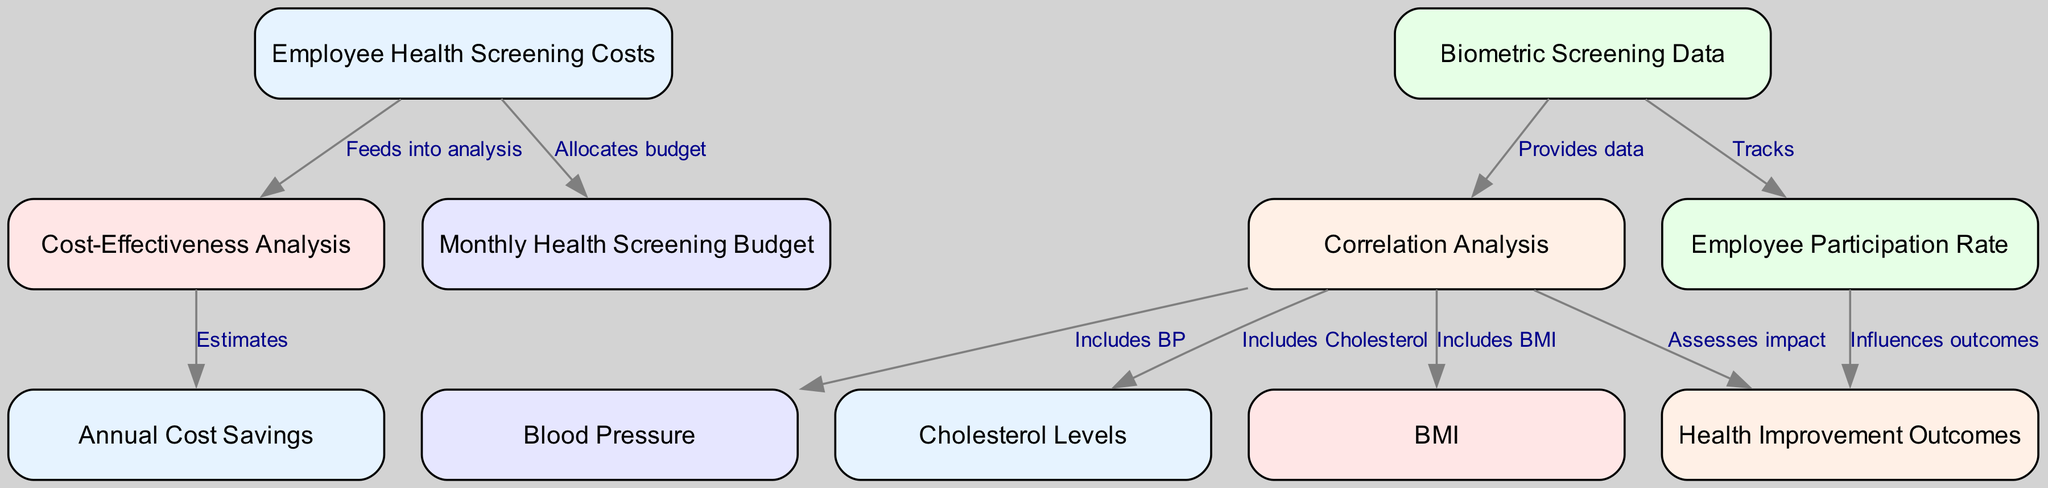What is the main focus of this diagram? The diagram primarily focuses on the various components and relationships surrounding employee health screening costs, including cost-effectiveness analysis and biometric screening data. This can be inferred from the central theme of the nodes represented, such as costs and analysis outcomes.
Answer: Employee Health Screening Costs How many nodes are there in the diagram? By counting each entry in the nodes list provided, there are a total of 11 nodes represented in the diagram.
Answer: 11 Which node influences health improvement outcomes? The diagram indicates that the "Employee Participation Rate" directly influences "Health Improvement Outcomes," as shown by the edge connecting these two nodes.
Answer: Employee Participation Rate What does the "Cost-Effectiveness Analysis" estimate? The "Cost-Effectiveness Analysis" estimates "Annual Cost Savings," evidenced by the directed edge going from the analysis to the savings node.
Answer: Annual Cost Savings Which components are included in the correlation analysis? The "Correlation Analysis" includes "Blood Pressure," "Cholesterol Levels," and "BMI," as these are directly connected to the analysis node in the diagram.
Answer: Blood Pressure, Cholesterol Levels, BMI What does the "Biometric Screening Data" track? The "Biometric Screening Data" tracks the "Employee Participation Rate," as indicated by the directed edge between these two nodes in the diagram.
Answer: Employee Participation Rate How does the "Employee Health Screening Costs" affect the monthly budget? The "Employee Health Screening Costs" allocates budget to the "Monthly Health Screening Budget," according to the edge showing their relationship.
Answer: Allocates budget What is one of the health metrics that correlation analysis includes? The correlation analysis includes "Blood Pressure," as indicated by a direct connection from the analysis node to the blood pressure node.
Answer: Blood Pressure 